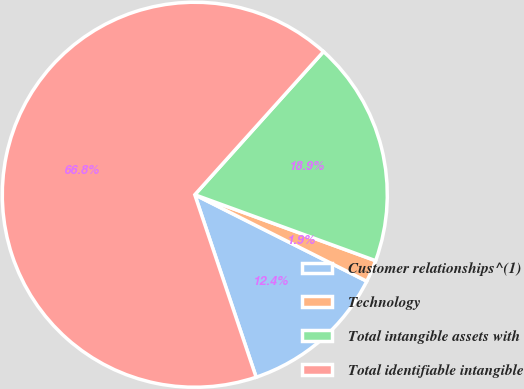Convert chart to OTSL. <chart><loc_0><loc_0><loc_500><loc_500><pie_chart><fcel>Customer relationships^(1)<fcel>Technology<fcel>Total intangible assets with<fcel>Total identifiable intangible<nl><fcel>12.42%<fcel>1.85%<fcel>18.91%<fcel>66.82%<nl></chart> 